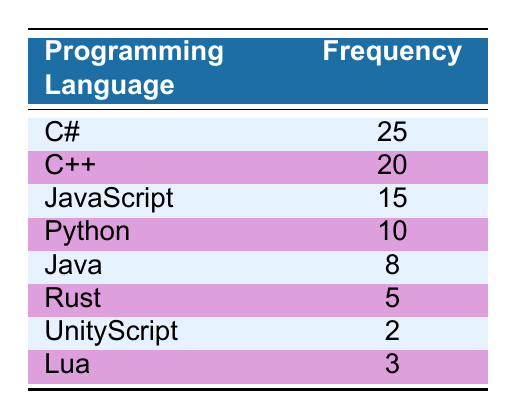What is the most popular programming language among young developers? The most popular programming language can be identified by looking for the language with the highest frequency value in the table. C# has the highest frequency of 25.
Answer: C# How many young developers are using JavaScript? The frequency of JavaScript as shown in the table is 15, indicating that 15 young developers are using it.
Answer: 15 What is the total number of young developers using C++ and Python combined? To find the total, we need to add the frequencies of C++ and Python. C++ has a frequency of 20 and Python has a frequency of 10. So, 20 + 10 = 30.
Answer: 30 Is Rust more popular than Java? By comparing the frequency values in the table, Rust has a frequency of 5 while Java has a frequency of 8. Since 5 is less than 8, Rust is not more popular than Java.
Answer: No What is the average frequency of the programming languages listed in the table? To calculate the average frequency, we first sum all the frequencies: 25 (C#) + 20 (C++) + 15 (JavaScript) + 10 (Python) + 8 (Java) + 5 (Rust) + 2 (UnityScript) + 3 (Lua) = 88. There are 8 languages, so the average is 88 / 8 = 11.
Answer: 11 How many more developers are using C# compared to Lua? The frequency of C# is 25 and that of Lua is 3. To find how many more developers are using C#, we subtract the frequency of Lua from that of C#: 25 - 3 = 22.
Answer: 22 Which programming language has the least number of young developers? By checking the frequencies in the table, UnityScript has the lowest frequency of 2, indicating that it is used by the least number of young developers.
Answer: UnityScript Can you name a programming language that is used by at least 10 young developers? By reviewing the table, C# (25), C++ (20), JavaScript (15), and Python (10) all have frequencies of 10 or more. Therefore, any of these languages meet the criteria.
Answer: C#, C++, JavaScript, Python 